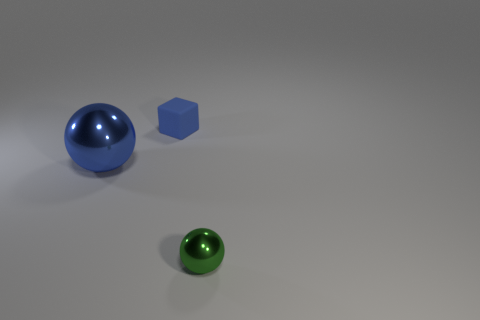Add 1 balls. How many objects exist? 4 Subtract all balls. How many objects are left? 1 Add 2 large blue spheres. How many large blue spheres exist? 3 Subtract 0 cyan cylinders. How many objects are left? 3 Subtract all matte cylinders. Subtract all blue things. How many objects are left? 1 Add 1 matte cubes. How many matte cubes are left? 2 